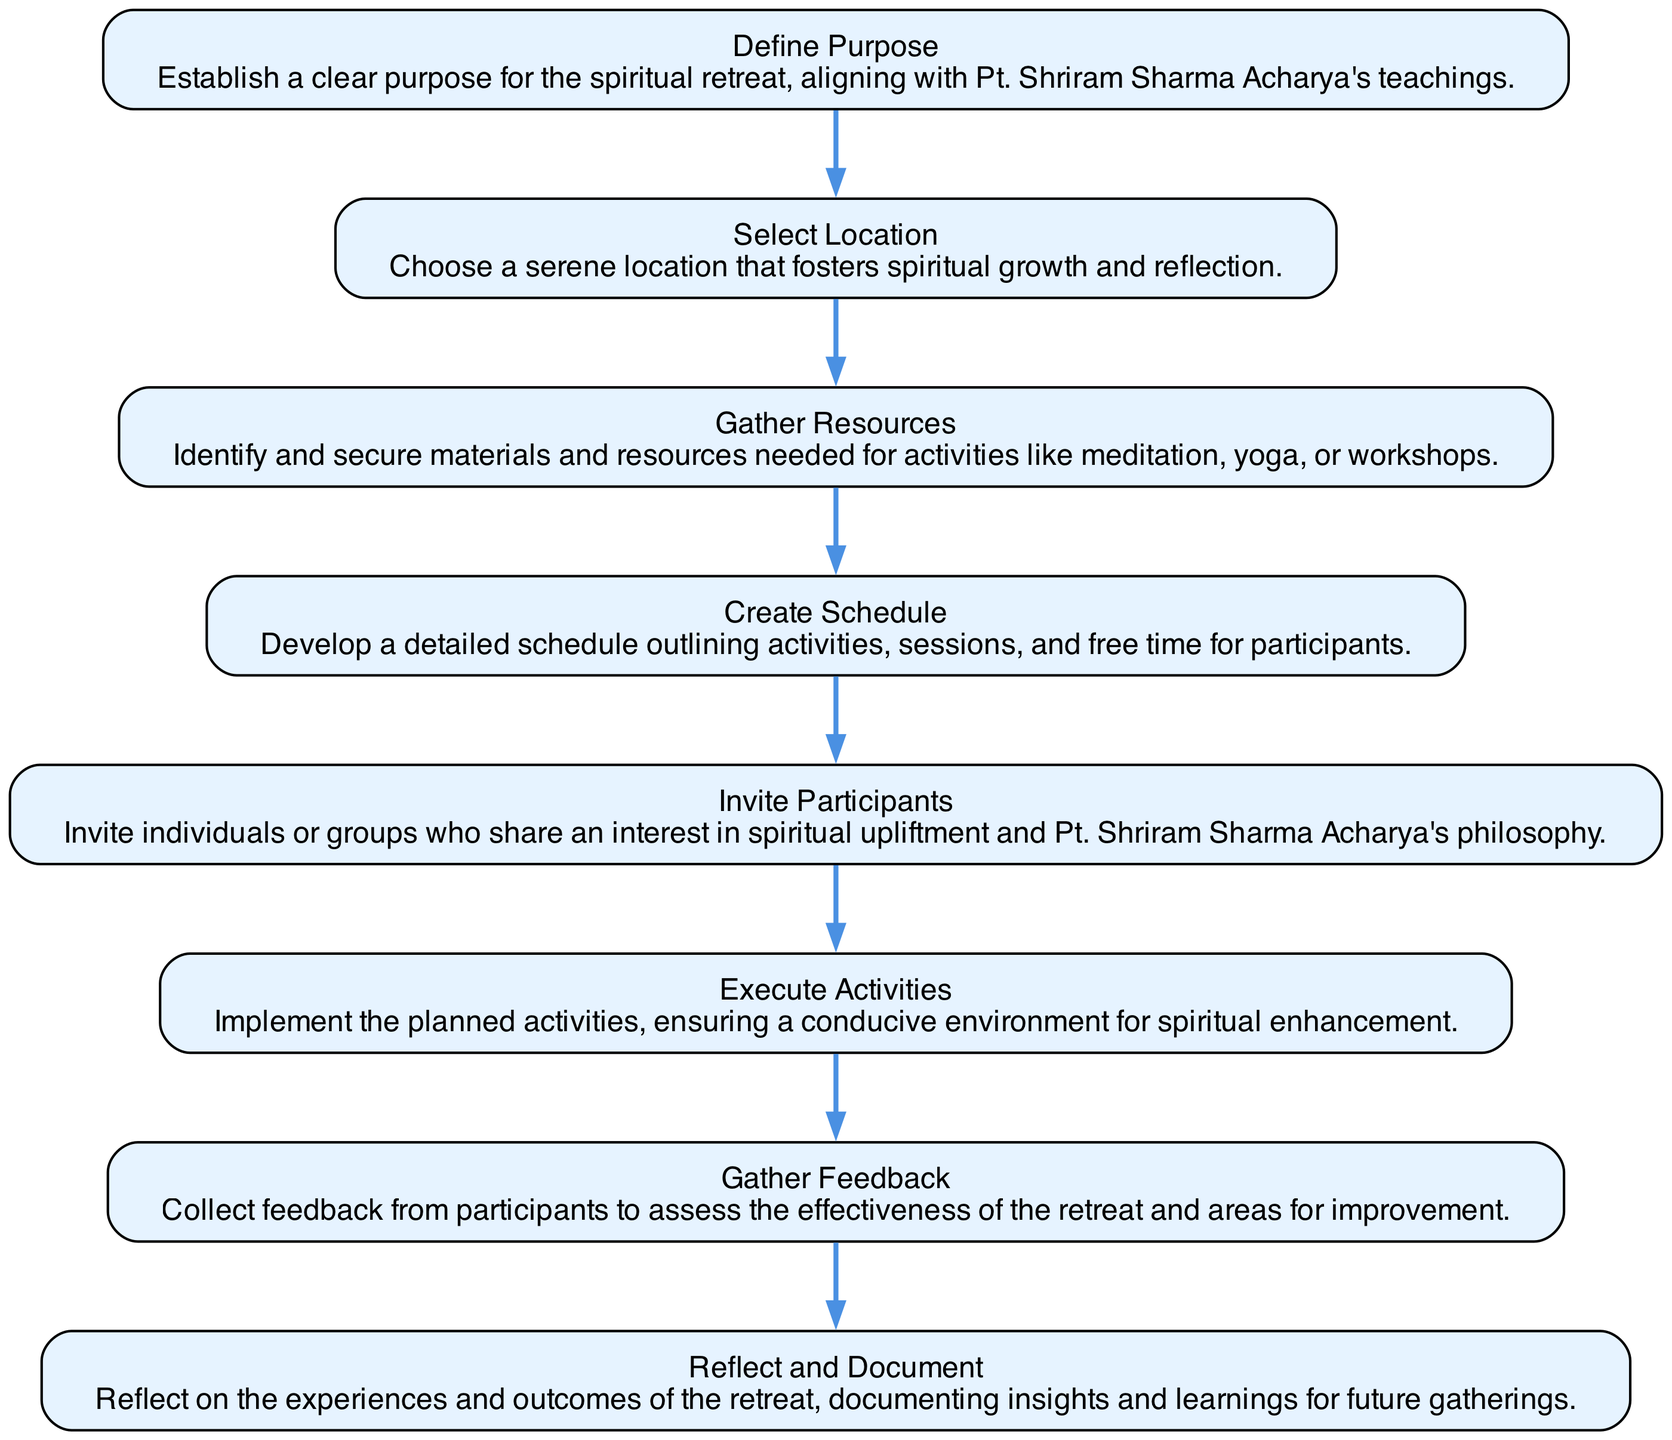What is the first step in the organizing process? The first step in the diagram is identified as "Define Purpose," which is represented by the first node in the directed graph.
Answer: Define Purpose How many nodes are present in the diagram? The diagram consists of 8 nodes, each representing a distinct step in the organizing process of a spiritual retreat, as listed in the data.
Answer: 8 Which step follows "Select Location"? "Gather Resources" follows "Select Location," as indicated by the directed edge that connects node 2 to node 3 in the diagram.
Answer: Gather Resources What is the last step in the process? The last step in the organizing process, according to the directed graph, is "Reflect and Document," which is the eighth node in the sequence.
Answer: Reflect and Document How many connections are there in total? There are 7 connections in the diagram, as each connection represents a link between consecutive steps in the organizing process.
Answer: 7 Which node is linked immediately after "Execute Activities"? "Gather Feedback" is linked immediately after "Execute Activities," as represented by the directed edge from node 6 to node 7.
Answer: Gather Feedback What is the relationship between "Create Schedule" and "Invite Participants"? "Create Schedule" directly leads to "Invite Participants," meaning that after developing a schedule, the next action is to invite participants, as shown by the connection from node 4 to node 5.
Answer: Directly leads to Which node describes the purpose of the retreat? The node that describes the purpose of the retreat is "Define Purpose," which establishes the foundation for planning the retreat based on Pt. Shriram Sharma Acharya's teachings.
Answer: Define Purpose 